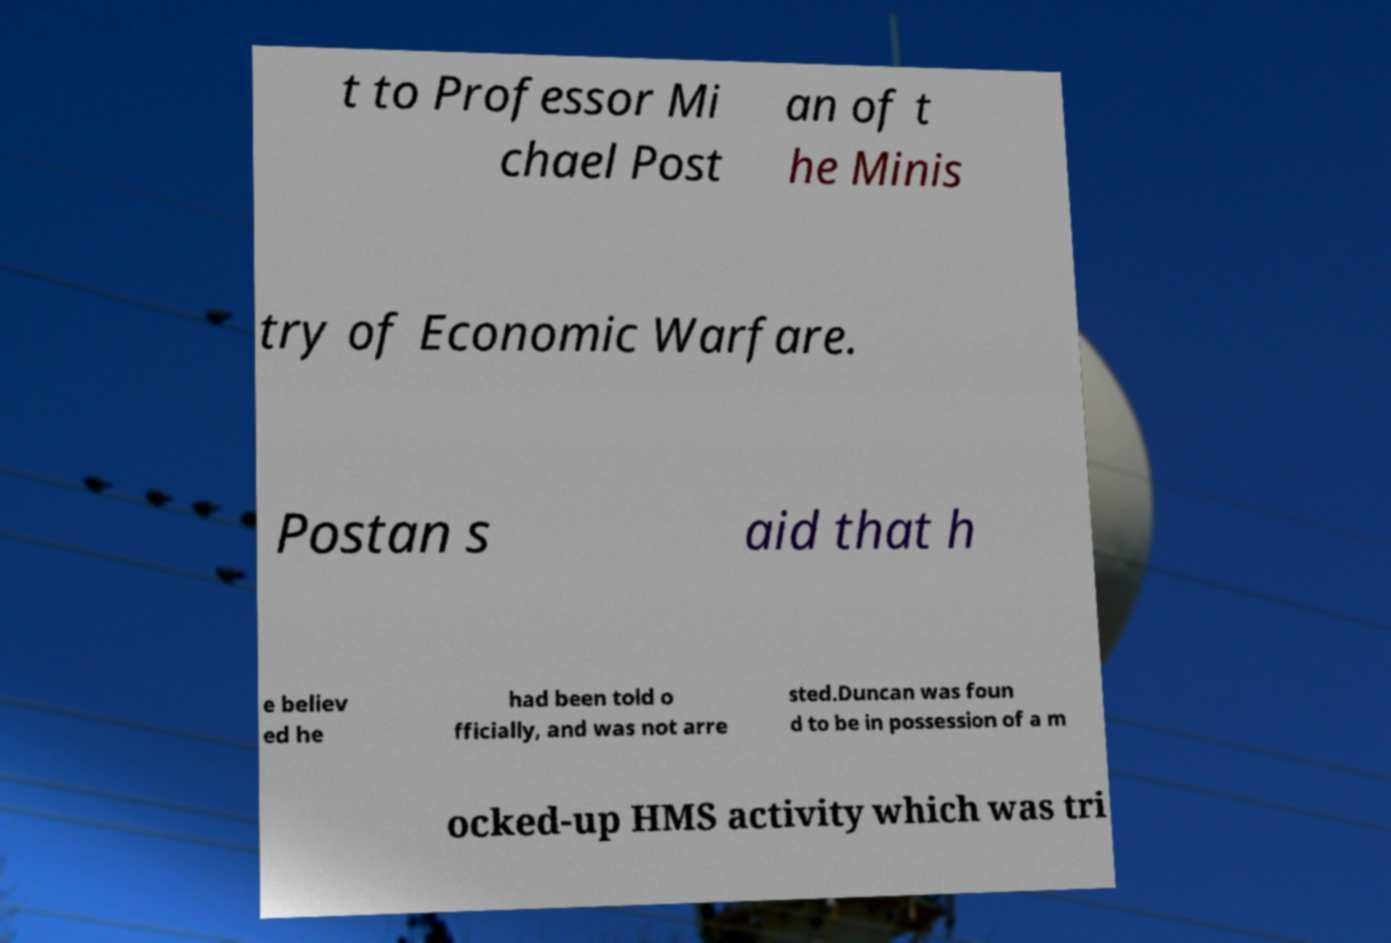Please read and relay the text visible in this image. What does it say? t to Professor Mi chael Post an of t he Minis try of Economic Warfare. Postan s aid that h e believ ed he had been told o fficially, and was not arre sted.Duncan was foun d to be in possession of a m ocked-up HMS activity which was tri 